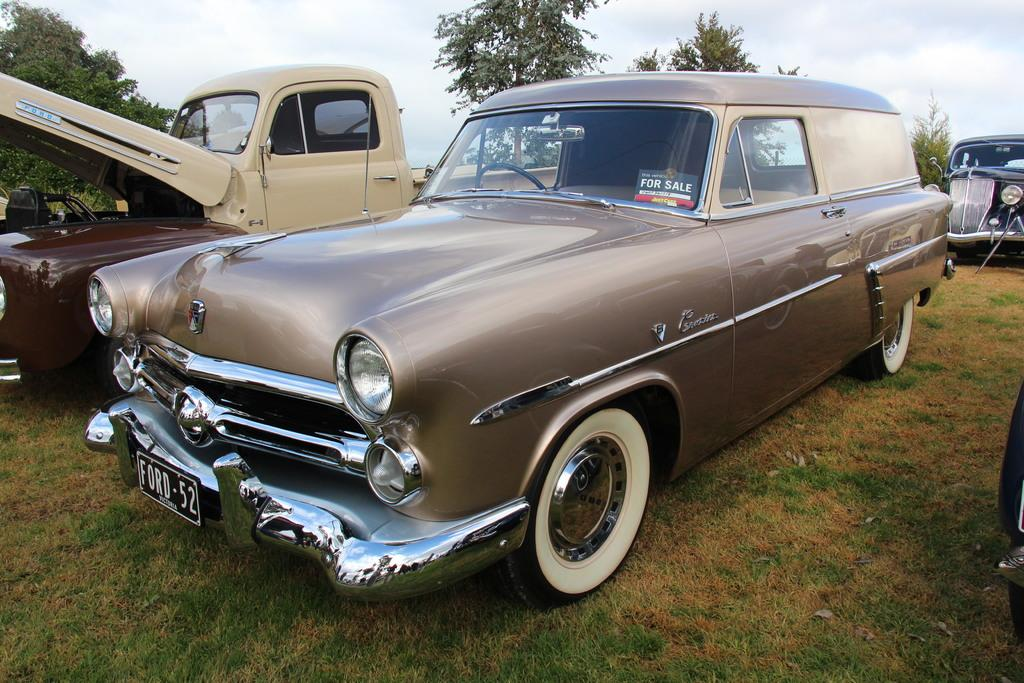<image>
Relay a brief, clear account of the picture shown. An old Ford car with the license plate Ford 52 parked next to another vehicle with the hood up. 